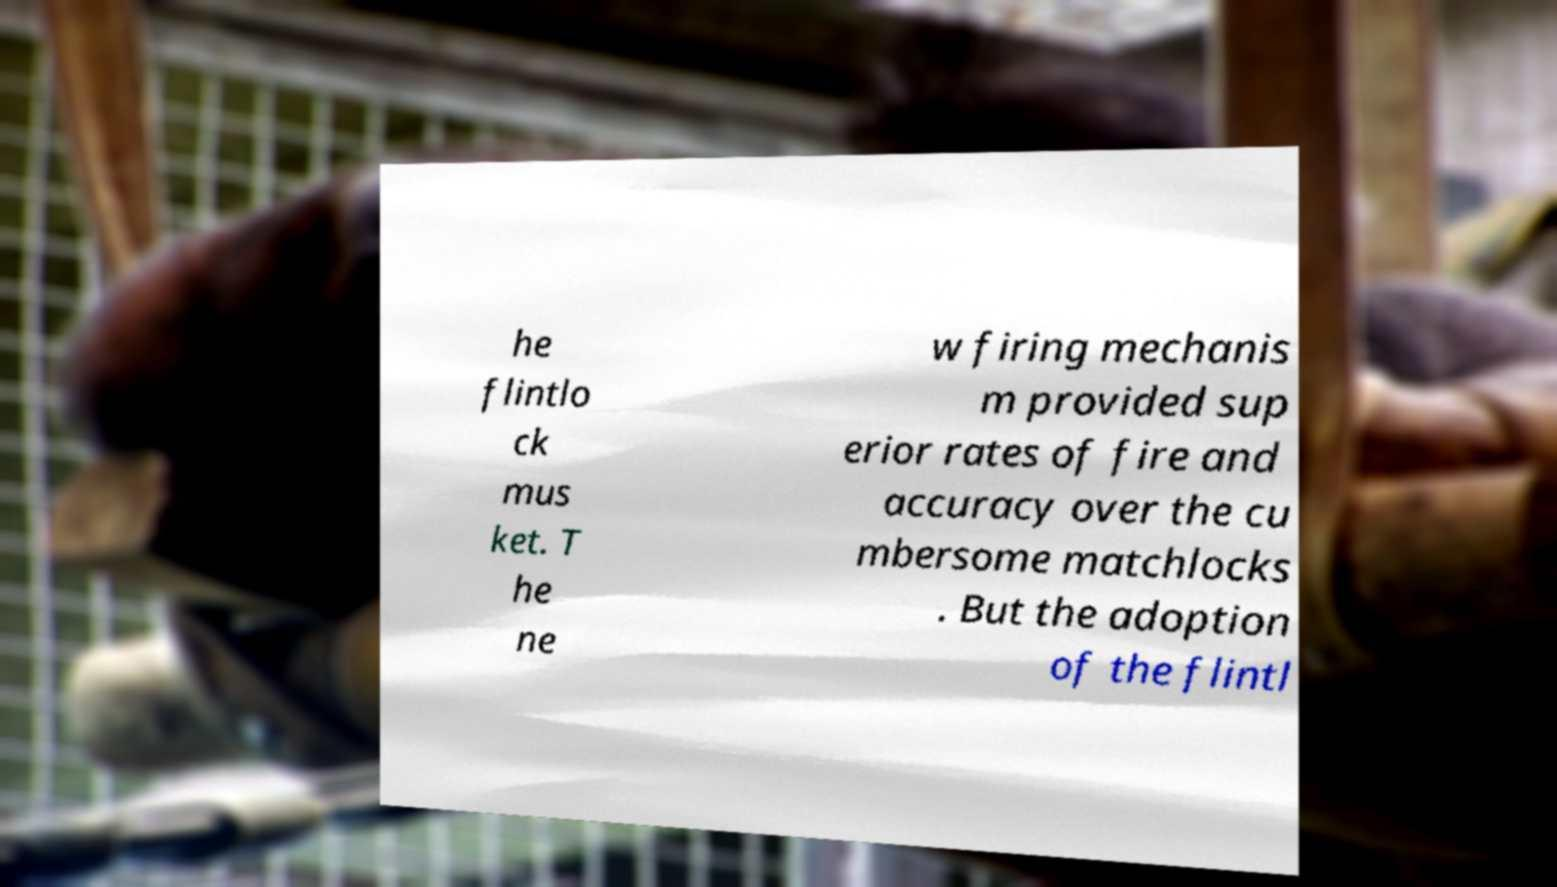Could you assist in decoding the text presented in this image and type it out clearly? he flintlo ck mus ket. T he ne w firing mechanis m provided sup erior rates of fire and accuracy over the cu mbersome matchlocks . But the adoption of the flintl 